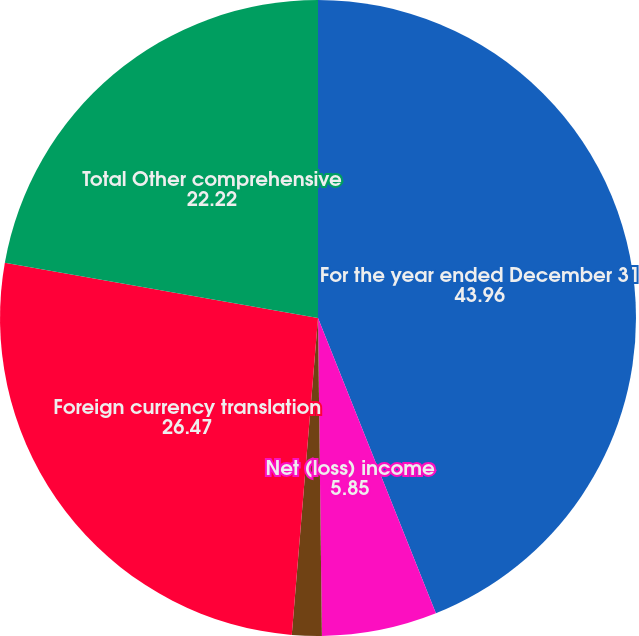Convert chart to OTSL. <chart><loc_0><loc_0><loc_500><loc_500><pie_chart><fcel>For the year ended December 31<fcel>Net (loss) income<fcel>Change in unrecognized net<fcel>Foreign currency translation<fcel>Total Other comprehensive<nl><fcel>43.96%<fcel>5.85%<fcel>1.51%<fcel>26.47%<fcel>22.22%<nl></chart> 